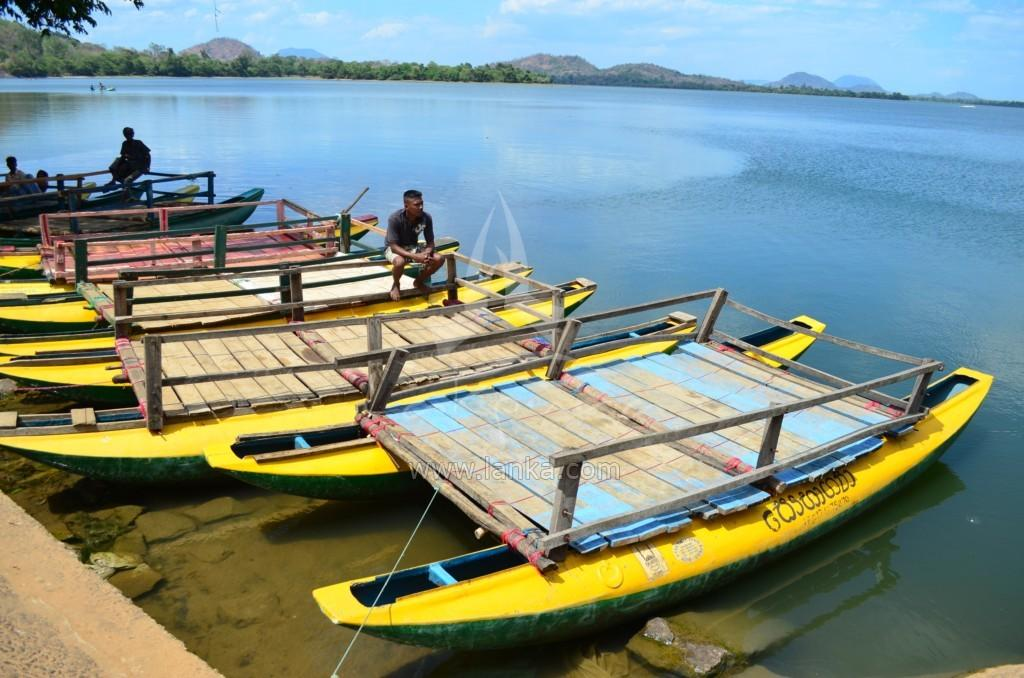What is happening on the water in the image? There are boats on the water in the image, and people are seated in the boats. What can be seen in the background of the image? There are trees and hills in the background of the image. What type of box is being used to crush the trees in the background? There is no box or tree-crushing activity present in the image. Can you tell me how many people were born on the boats in the image? There is no birth depicted in the image; it shows people seated in boats on the water. 